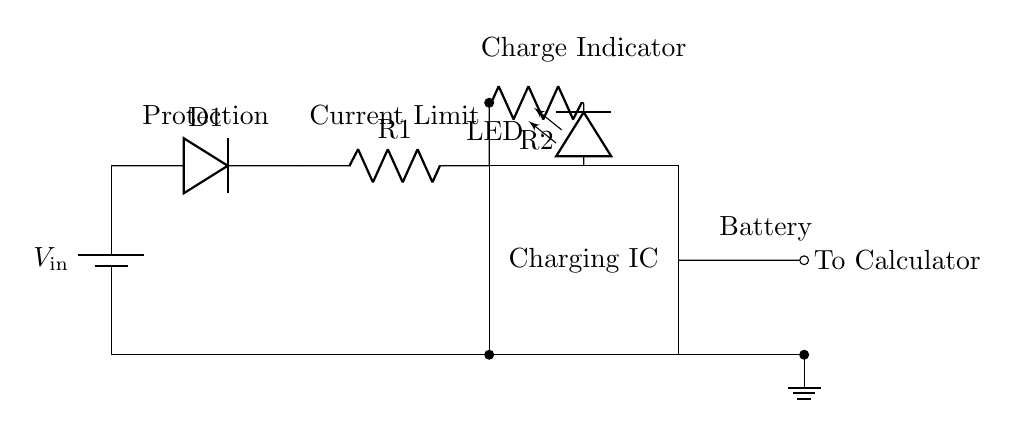What is the purpose of the diode in this circuit? The diode is used to allow current to flow in one direction only, protecting the circuit from potential reverse polarity issues. This ensures that the battery is charged correctly.
Answer: Protection What component indicates whether the battery is charging? The LED indicator shows whether the battery is charging. If the LED is lit, this indicates that charging is taking place, providing a visual indication of the status.
Answer: LED What is the role of the charging IC in the circuit? The charging IC regulates the charging process, ensuring that the battery receives the appropriate voltage and current for efficient charging while preventing overcharging or overheating.
Answer: Charging IC How many resistors are used in the circuit? There are two resistors in the circuit, one used for current limiting with respect to the LED indicator and the second for other circuit functions.
Answer: Two What is the output voltage level appropriate for charging the calculator's battery? The output voltage level will be approximately the same as the input voltage, but this may be regulated by the charging IC for battery compatibility; typically, it might be around 5 volts or according to specific battery requirements.
Answer: V_in What happens if the charging IC fails? If the charging IC fails, the battery may not charge properly, which could lead to undercharging or overcharging. This jeopardizes the safety and longevity of the battery and the device.
Answer: Charging failure 